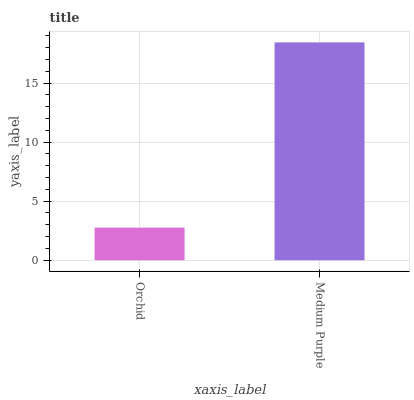Is Orchid the minimum?
Answer yes or no. Yes. Is Medium Purple the maximum?
Answer yes or no. Yes. Is Medium Purple the minimum?
Answer yes or no. No. Is Medium Purple greater than Orchid?
Answer yes or no. Yes. Is Orchid less than Medium Purple?
Answer yes or no. Yes. Is Orchid greater than Medium Purple?
Answer yes or no. No. Is Medium Purple less than Orchid?
Answer yes or no. No. Is Medium Purple the high median?
Answer yes or no. Yes. Is Orchid the low median?
Answer yes or no. Yes. Is Orchid the high median?
Answer yes or no. No. Is Medium Purple the low median?
Answer yes or no. No. 